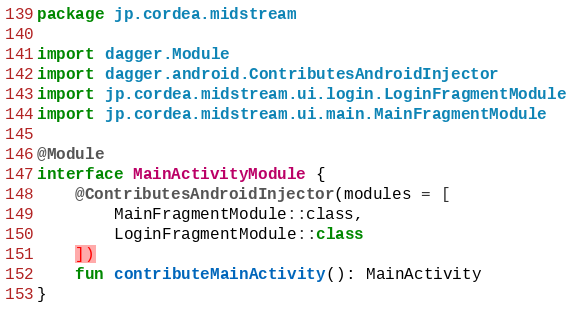<code> <loc_0><loc_0><loc_500><loc_500><_Kotlin_>package jp.cordea.midstream

import dagger.Module
import dagger.android.ContributesAndroidInjector
import jp.cordea.midstream.ui.login.LoginFragmentModule
import jp.cordea.midstream.ui.main.MainFragmentModule

@Module
interface MainActivityModule {
    @ContributesAndroidInjector(modules = [
        MainFragmentModule::class,
        LoginFragmentModule::class
    ])
    fun contributeMainActivity(): MainActivity
}
</code> 